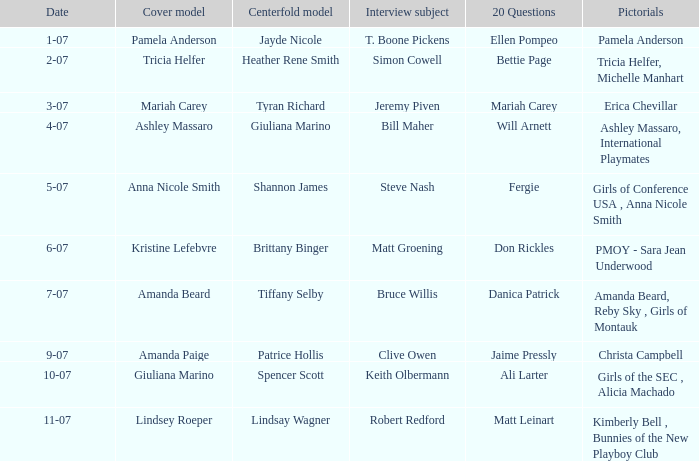Who answered the 20 questions on 10-07? Ali Larter. 